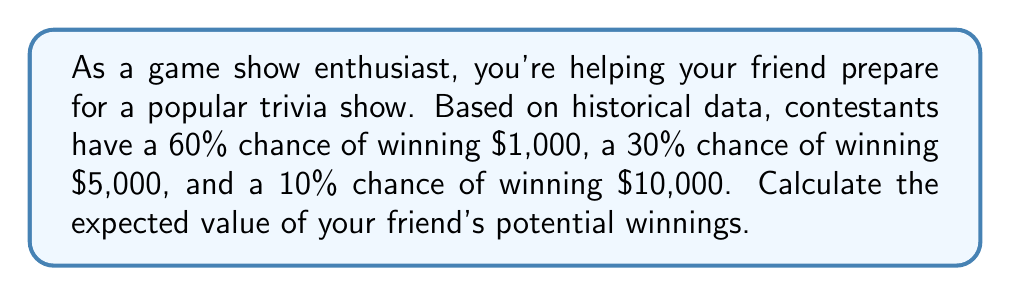What is the answer to this math problem? Let's approach this step-by-step:

1) The expected value is calculated by multiplying each possible outcome by its probability and then summing these products.

2) We have three possible outcomes:
   - $1,000 with 60% probability
   - $5,000 with 30% probability
   - $10,000 with 10% probability

3) Let's calculate the contribution of each outcome to the expected value:
   
   $1,000 outcome: $$1,000 \times 0.60 = 600$$
   
   $5,000 outcome: $$5,000 \times 0.30 = 1,500$$
   
   $10,000 outcome: $$10,000 \times 0.10 = 1,000$$

4) Now, we sum these values:

   $$E(\text{winnings}) = 600 + 1,500 + 1,000 = 3,100$$

Therefore, the expected value of your friend's potential winnings is $3,100.
Answer: $3,100 